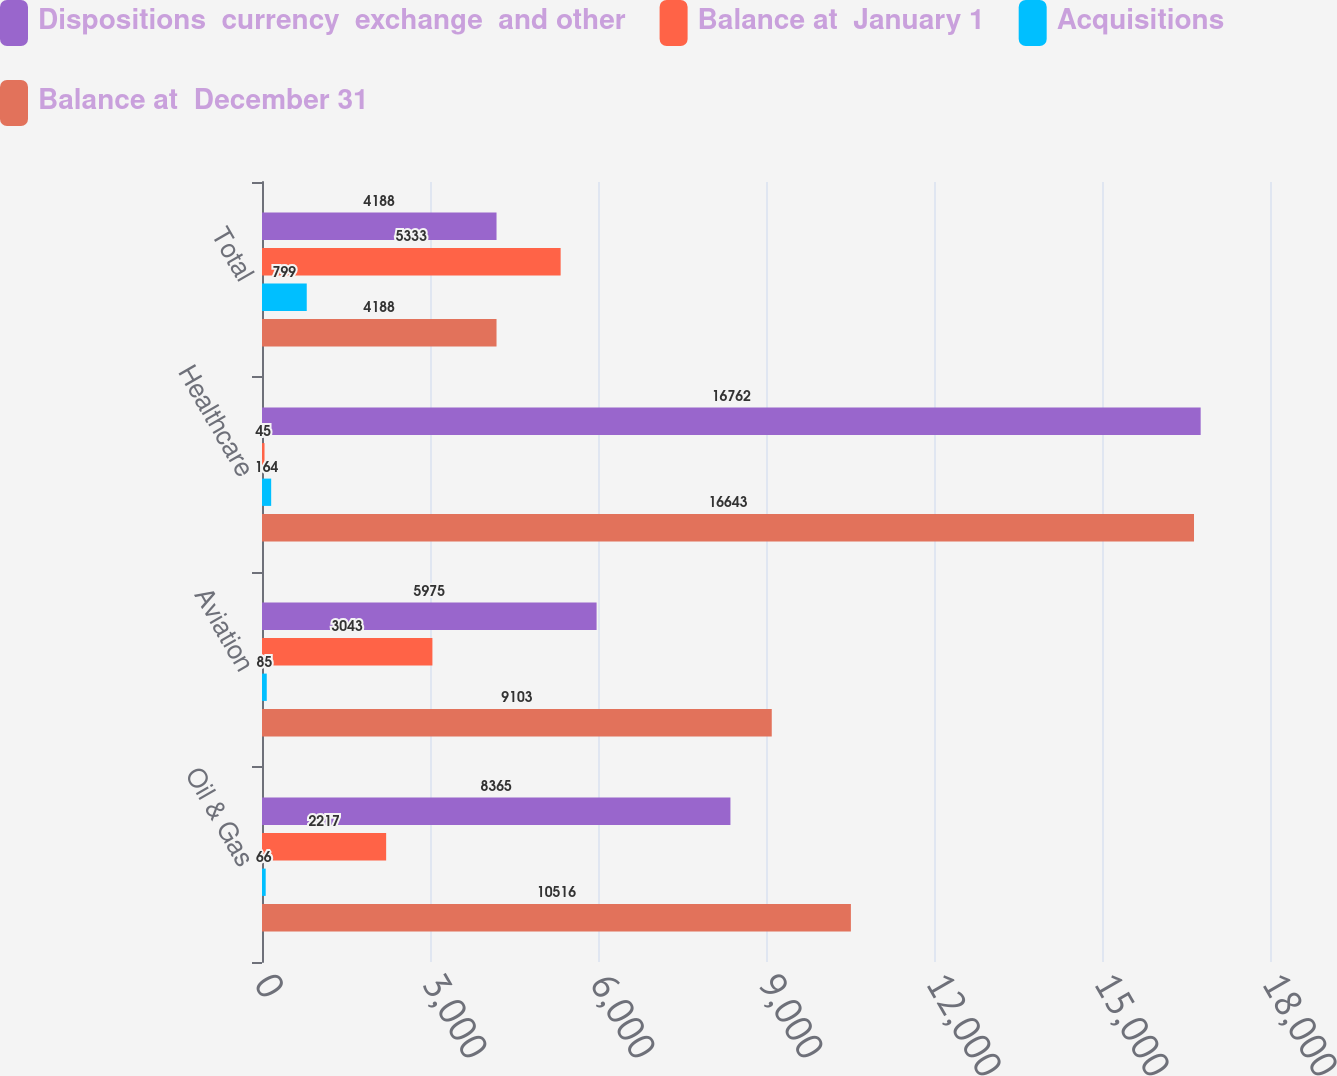Convert chart to OTSL. <chart><loc_0><loc_0><loc_500><loc_500><stacked_bar_chart><ecel><fcel>Oil & Gas<fcel>Aviation<fcel>Healthcare<fcel>Total<nl><fcel>Dispositions  currency  exchange  and other<fcel>8365<fcel>5975<fcel>16762<fcel>4188<nl><fcel>Balance at  January 1<fcel>2217<fcel>3043<fcel>45<fcel>5333<nl><fcel>Acquisitions<fcel>66<fcel>85<fcel>164<fcel>799<nl><fcel>Balance at  December 31<fcel>10516<fcel>9103<fcel>16643<fcel>4188<nl></chart> 